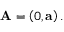Convert formula to latex. <formula><loc_0><loc_0><loc_500><loc_500>A = \left ( 0 , a \right ) .</formula> 